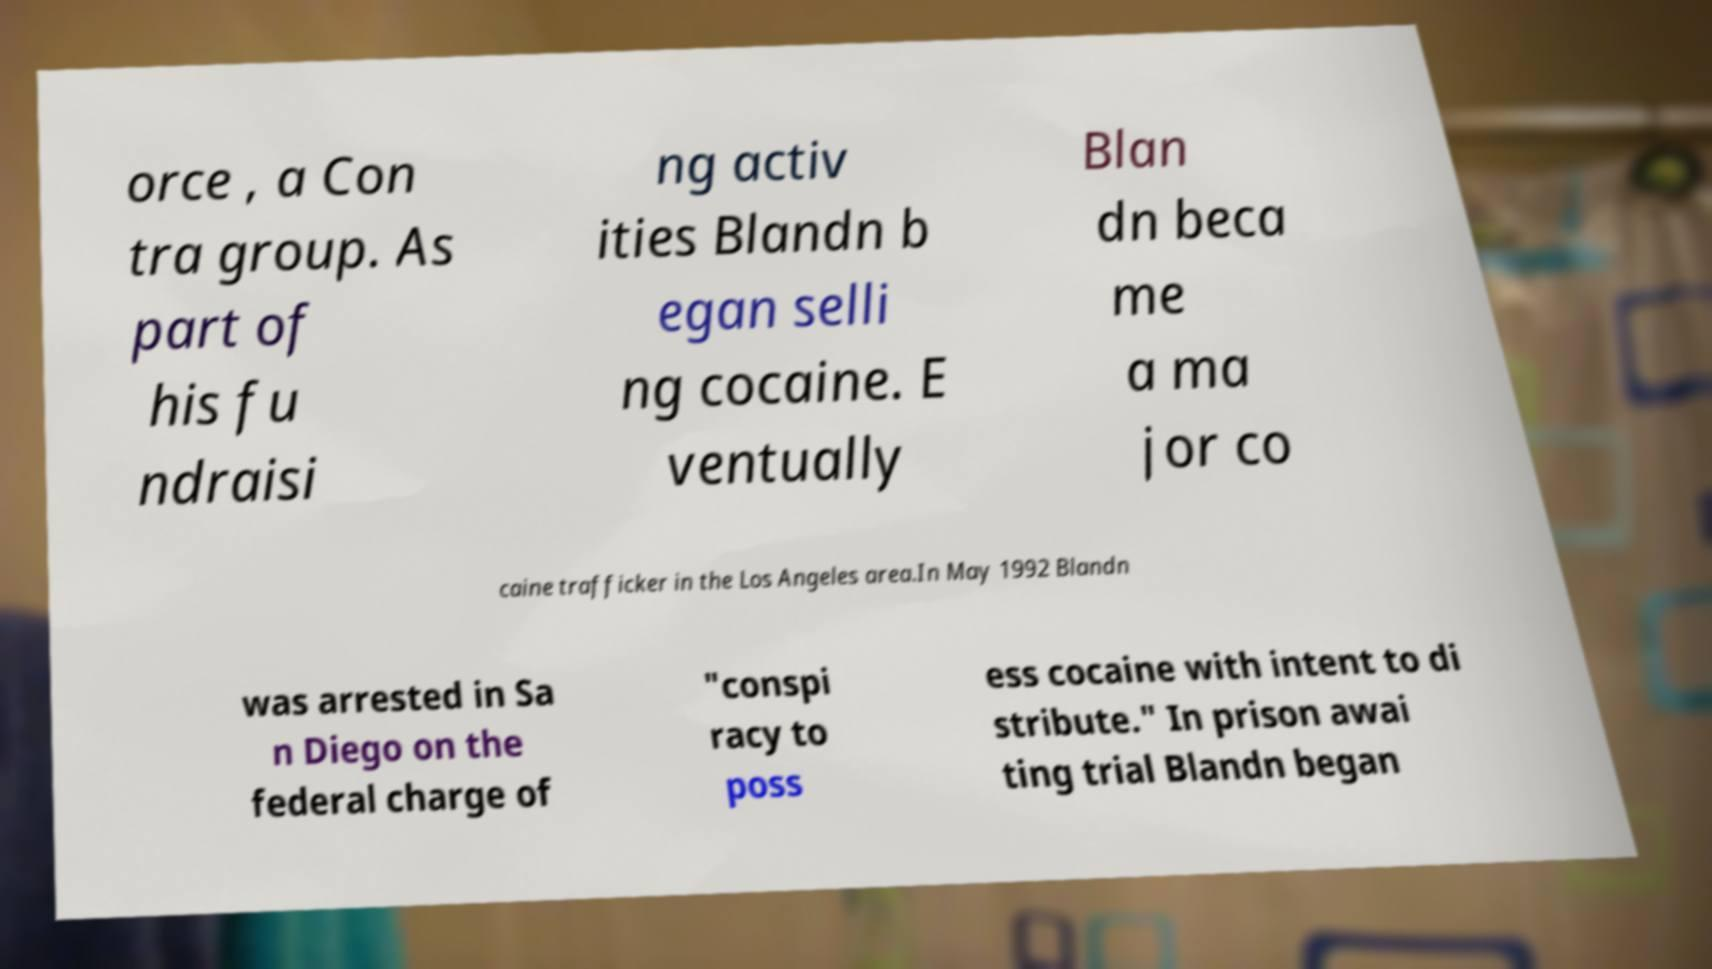Please read and relay the text visible in this image. What does it say? orce , a Con tra group. As part of his fu ndraisi ng activ ities Blandn b egan selli ng cocaine. E ventually Blan dn beca me a ma jor co caine trafficker in the Los Angeles area.In May 1992 Blandn was arrested in Sa n Diego on the federal charge of "conspi racy to poss ess cocaine with intent to di stribute." In prison awai ting trial Blandn began 